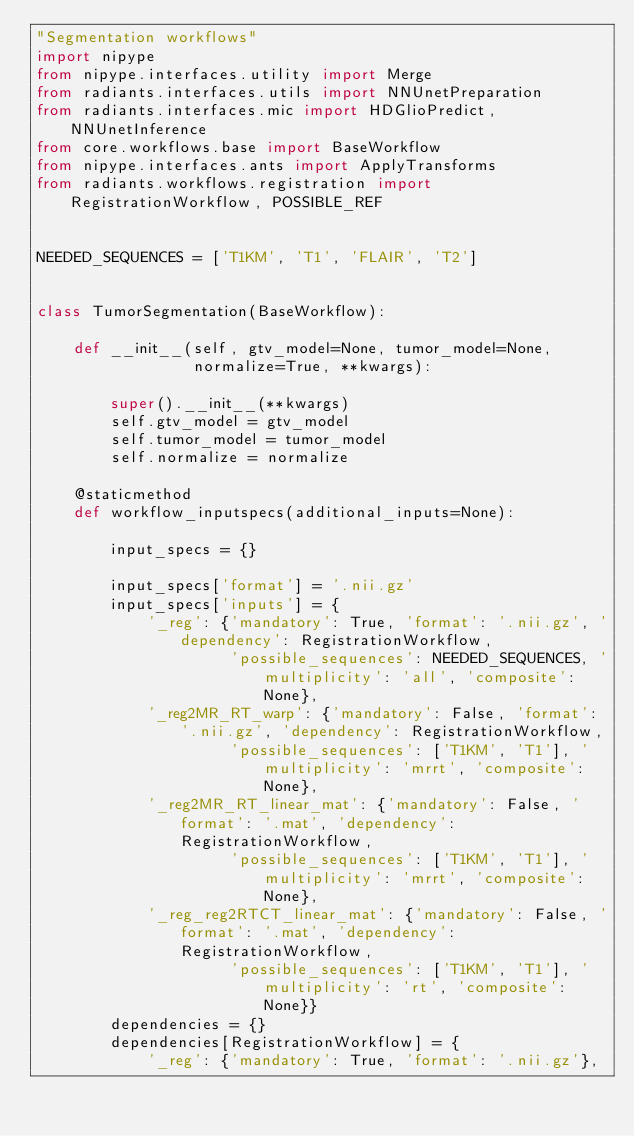Convert code to text. <code><loc_0><loc_0><loc_500><loc_500><_Python_>"Segmentation workflows"
import nipype
from nipype.interfaces.utility import Merge
from radiants.interfaces.utils import NNUnetPreparation
from radiants.interfaces.mic import HDGlioPredict, NNUnetInference
from core.workflows.base import BaseWorkflow
from nipype.interfaces.ants import ApplyTransforms
from radiants.workflows.registration import RegistrationWorkflow, POSSIBLE_REF


NEEDED_SEQUENCES = ['T1KM', 'T1', 'FLAIR', 'T2']


class TumorSegmentation(BaseWorkflow):
    
    def __init__(self, gtv_model=None, tumor_model=None,
                 normalize=True, **kwargs):
        
        super().__init__(**kwargs)
        self.gtv_model = gtv_model
        self.tumor_model = tumor_model
        self.normalize = normalize

    @staticmethod
    def workflow_inputspecs(additional_inputs=None):

        input_specs = {}

        input_specs['format'] = '.nii.gz'
        input_specs['inputs'] = {
            '_reg': {'mandatory': True, 'format': '.nii.gz', 'dependency': RegistrationWorkflow,
                     'possible_sequences': NEEDED_SEQUENCES, 'multiplicity': 'all', 'composite': None},
            '_reg2MR_RT_warp': {'mandatory': False, 'format': '.nii.gz', 'dependency': RegistrationWorkflow,
                     'possible_sequences': ['T1KM', 'T1'], 'multiplicity': 'mrrt', 'composite': None},
            '_reg2MR_RT_linear_mat': {'mandatory': False, 'format': '.mat', 'dependency': RegistrationWorkflow,
                     'possible_sequences': ['T1KM', 'T1'], 'multiplicity': 'mrrt', 'composite': None},
            '_reg_reg2RTCT_linear_mat': {'mandatory': False, 'format': '.mat', 'dependency': RegistrationWorkflow,
                     'possible_sequences': ['T1KM', 'T1'], 'multiplicity': 'rt', 'composite': None}}
        dependencies = {}
        dependencies[RegistrationWorkflow] = {
            '_reg': {'mandatory': True, 'format': '.nii.gz'},</code> 